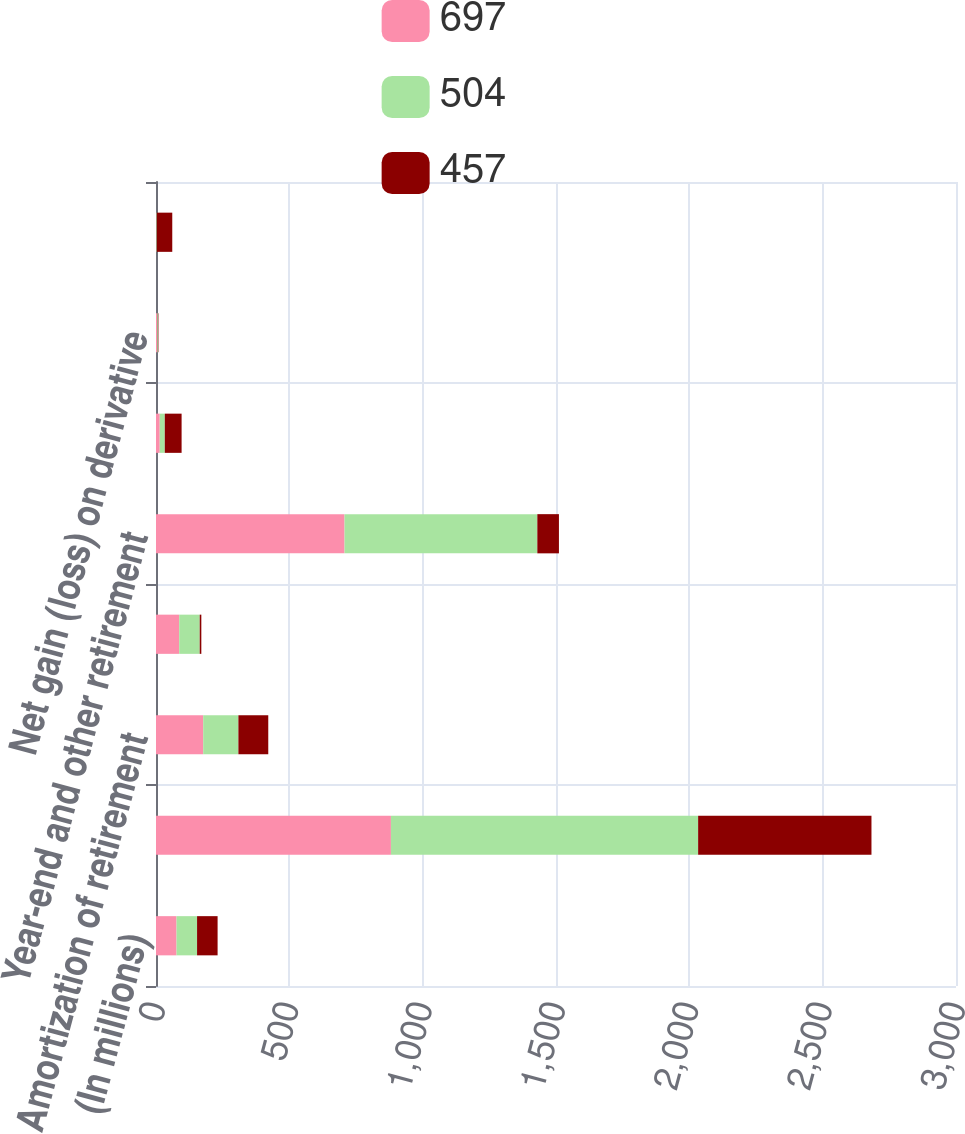<chart> <loc_0><loc_0><loc_500><loc_500><stacked_bar_chart><ecel><fcel>(In millions)<fcel>Net earnings<fcel>Amortization of retirement<fcel>Mid-year remeasurement of<fcel>Year-end and other retirement<fcel>Foreign currency translation<fcel>Net gain (loss) on derivative<fcel>Net unrealized gain (loss) on<nl><fcel>697<fcel>77<fcel>881<fcel>177<fcel>87<fcel>707<fcel>14<fcel>4<fcel>1<nl><fcel>504<fcel>77<fcel>1152<fcel>132<fcel>77<fcel>723<fcel>19<fcel>3<fcel>2<nl><fcel>457<fcel>77<fcel>650<fcel>112<fcel>6<fcel>81<fcel>63<fcel>2<fcel>58<nl></chart> 